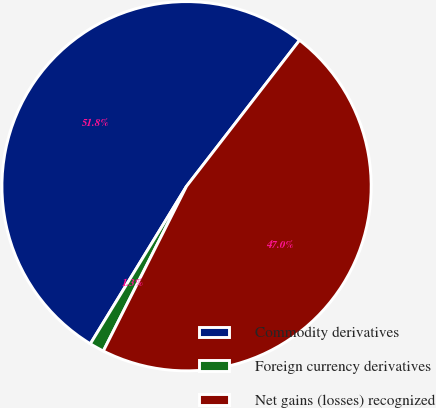<chart> <loc_0><loc_0><loc_500><loc_500><pie_chart><fcel>Commodity derivatives<fcel>Foreign currency derivatives<fcel>Net gains (losses) recognized<nl><fcel>51.76%<fcel>1.28%<fcel>46.96%<nl></chart> 